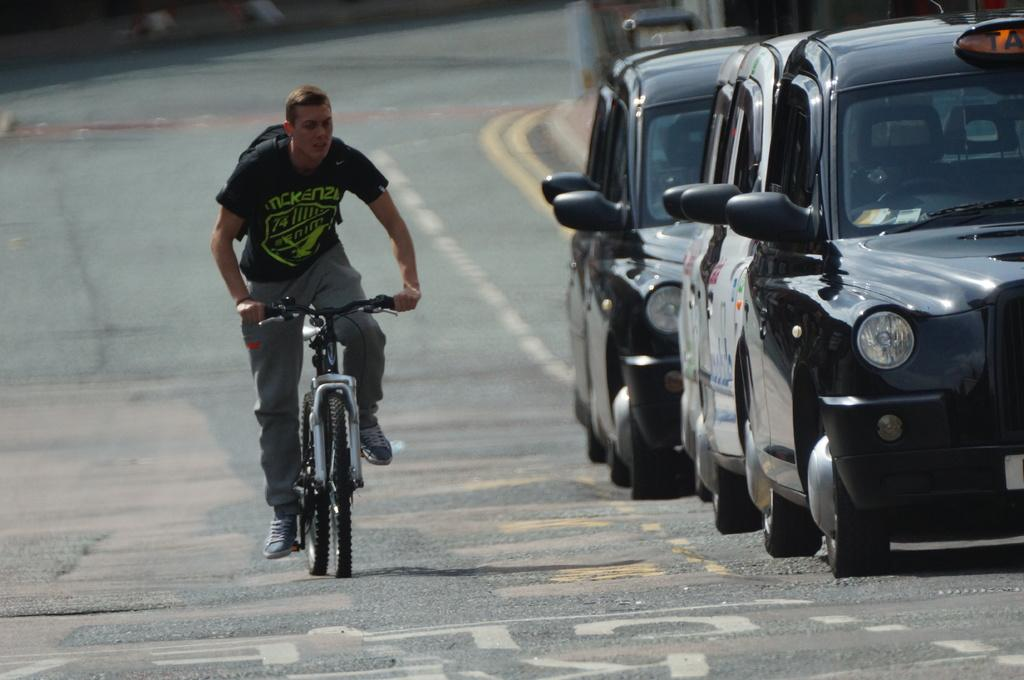What is the main subject of the image? There is a person riding a bicycle in the image. Where is the person riding the bicycle? The person is on a road. Are there any other vehicles in the image? Yes, there are cars in the image. Can you describe the background of the image? The background of the image is blurred. How many babies are being carried by the beast in the image? There is no beast or babies present in the image. 